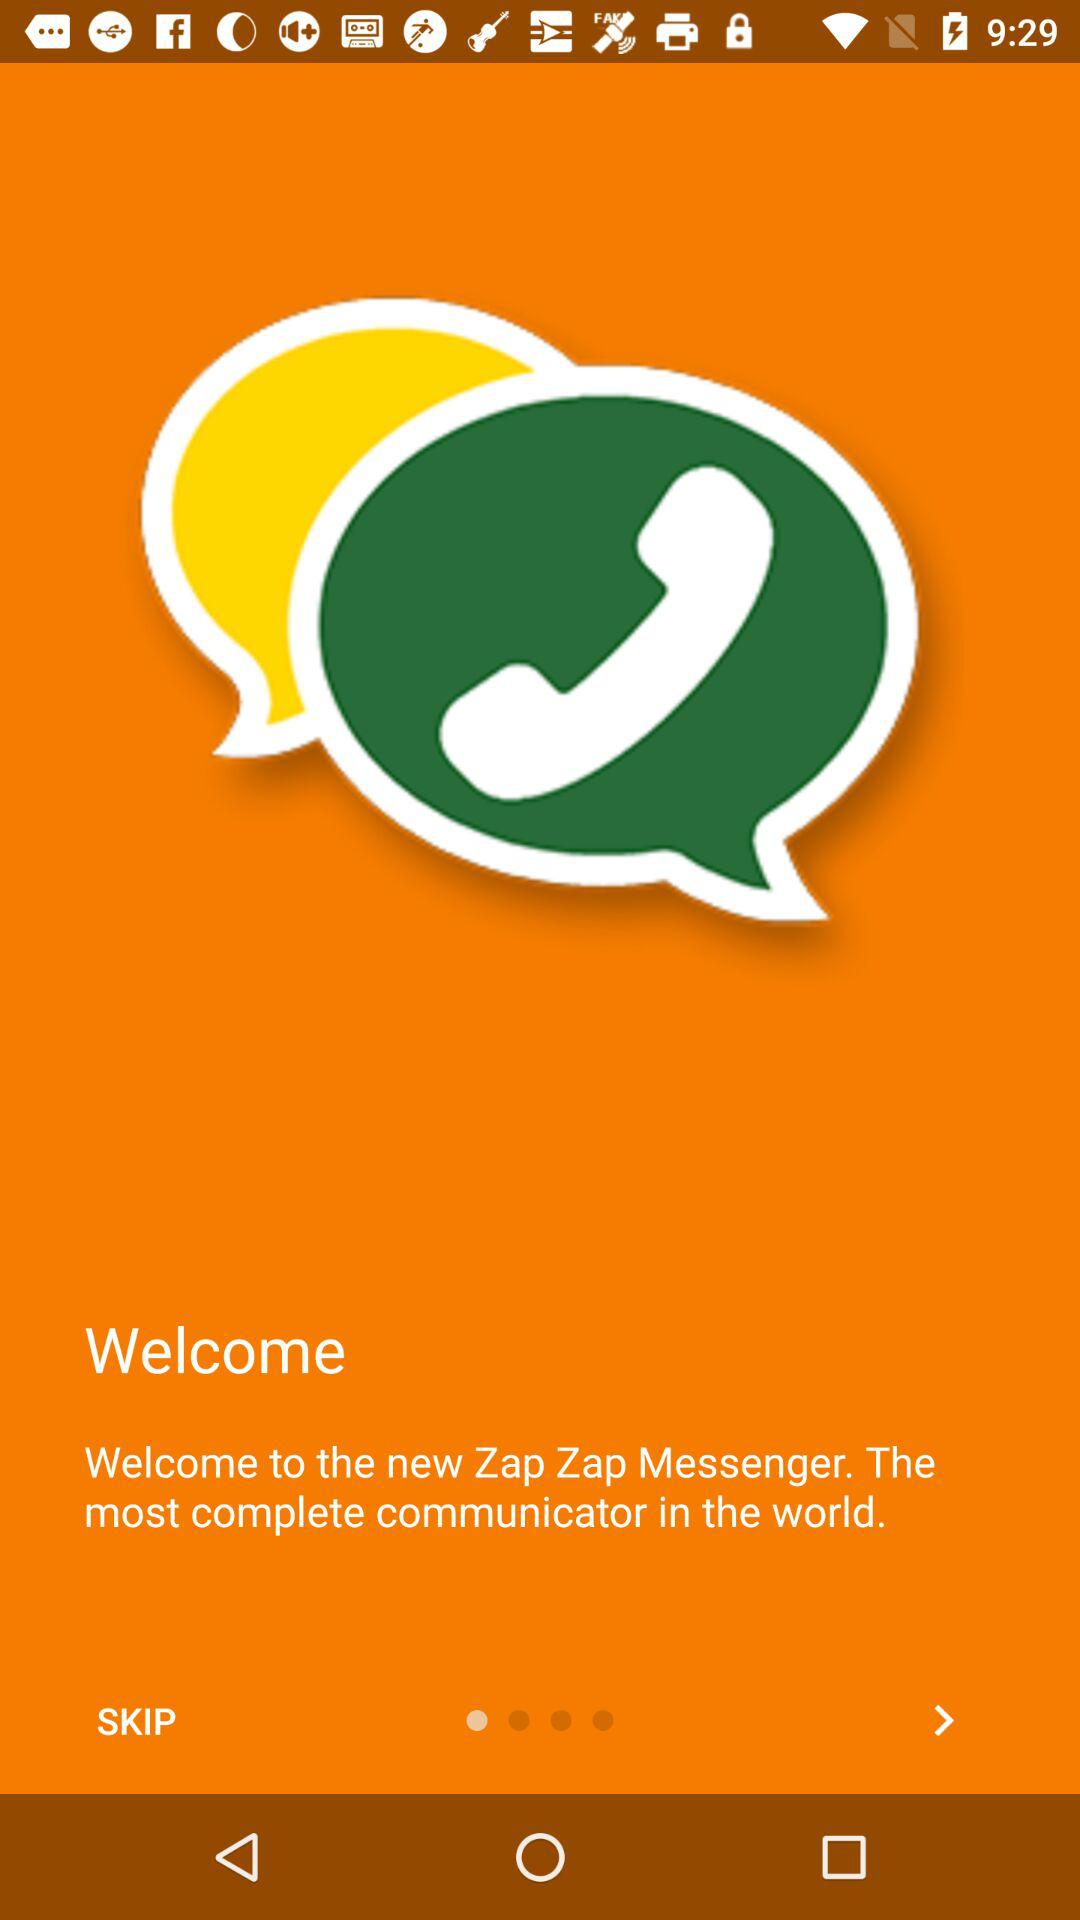What’s the app name? The app name is "Zap Zap Messenger". 